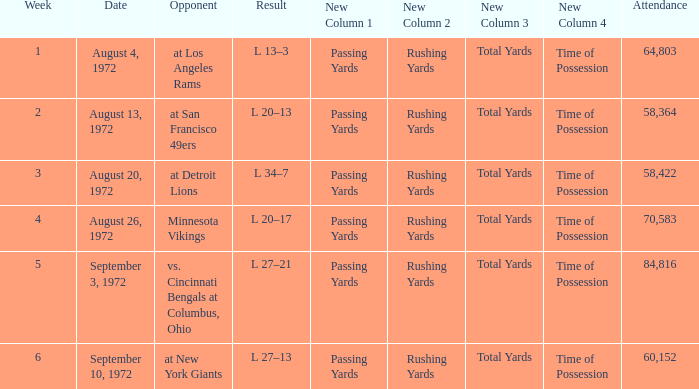How many weeks had an attendance larger than 84,816? 0.0. 